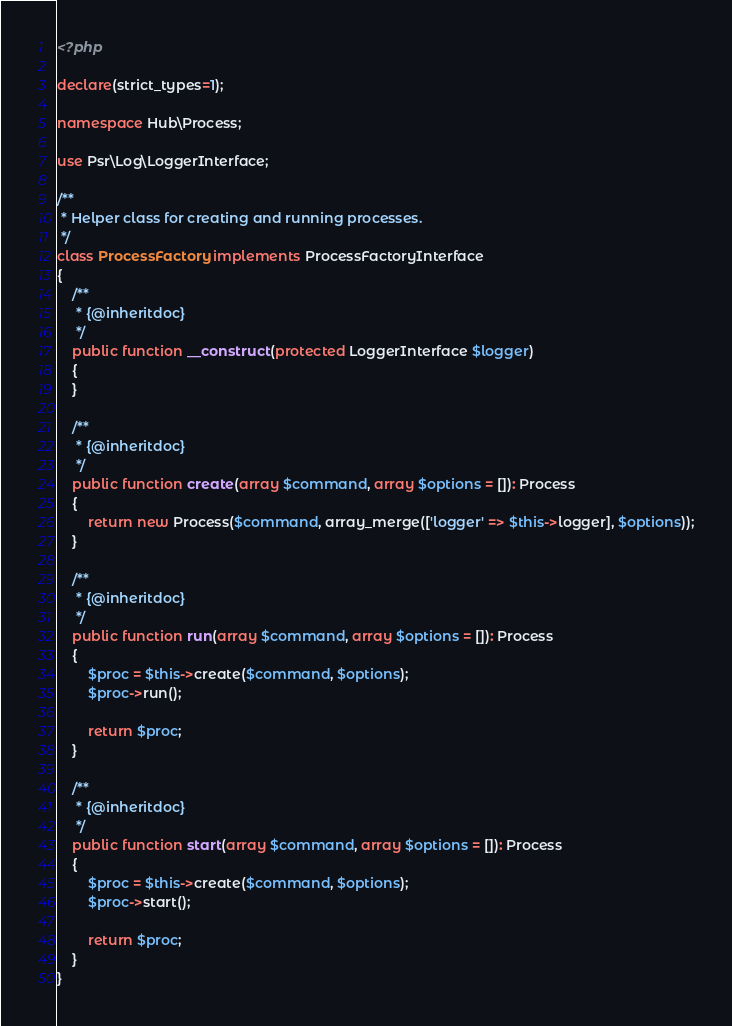Convert code to text. <code><loc_0><loc_0><loc_500><loc_500><_PHP_><?php

declare(strict_types=1);

namespace Hub\Process;

use Psr\Log\LoggerInterface;

/**
 * Helper class for creating and running processes.
 */
class ProcessFactory implements ProcessFactoryInterface
{
    /**
     * {@inheritdoc}
     */
    public function __construct(protected LoggerInterface $logger)
    {
    }

    /**
     * {@inheritdoc}
     */
    public function create(array $command, array $options = []): Process
    {
        return new Process($command, array_merge(['logger' => $this->logger], $options));
    }

    /**
     * {@inheritdoc}
     */
    public function run(array $command, array $options = []): Process
    {
        $proc = $this->create($command, $options);
        $proc->run();

        return $proc;
    }

    /**
     * {@inheritdoc}
     */
    public function start(array $command, array $options = []): Process
    {
        $proc = $this->create($command, $options);
        $proc->start();

        return $proc;
    }
}
</code> 